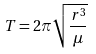Convert formula to latex. <formula><loc_0><loc_0><loc_500><loc_500>T = 2 \pi \sqrt { \frac { r ^ { 3 } } { \mu } }</formula> 